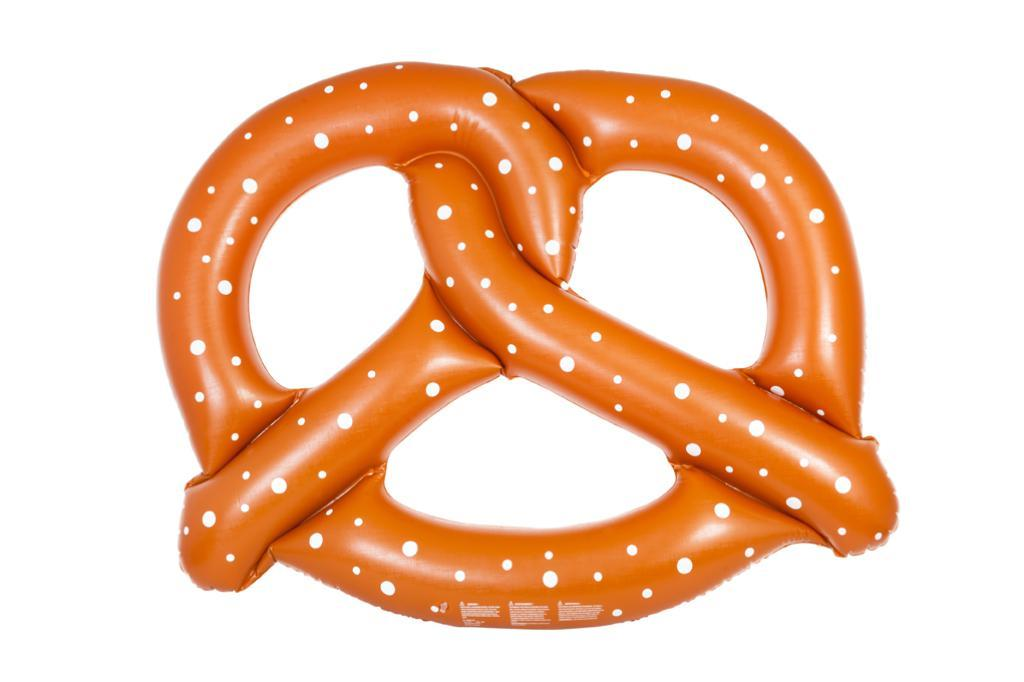What is the main object in the center of the image? There is an orange color object in the center of the image. What is the object's purpose or function? The object appears to be a pool float. What color is the background of the image? The background of the image is white in color. How many wings can be seen on the lizards in the image? There are no lizards present in the image, so there are no wings to count. 